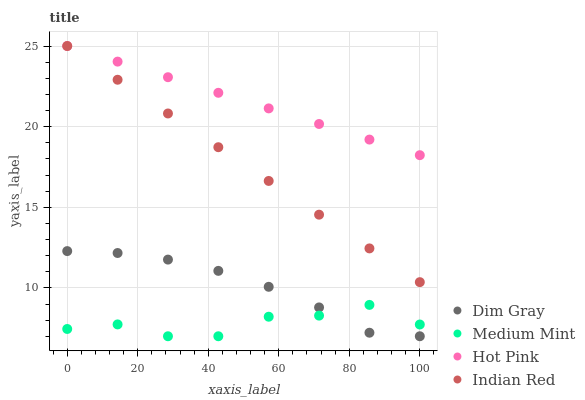Does Medium Mint have the minimum area under the curve?
Answer yes or no. Yes. Does Hot Pink have the maximum area under the curve?
Answer yes or no. Yes. Does Dim Gray have the minimum area under the curve?
Answer yes or no. No. Does Dim Gray have the maximum area under the curve?
Answer yes or no. No. Is Indian Red the smoothest?
Answer yes or no. Yes. Is Medium Mint the roughest?
Answer yes or no. Yes. Is Dim Gray the smoothest?
Answer yes or no. No. Is Dim Gray the roughest?
Answer yes or no. No. Does Medium Mint have the lowest value?
Answer yes or no. Yes. Does Indian Red have the lowest value?
Answer yes or no. No. Does Hot Pink have the highest value?
Answer yes or no. Yes. Does Dim Gray have the highest value?
Answer yes or no. No. Is Medium Mint less than Indian Red?
Answer yes or no. Yes. Is Indian Red greater than Medium Mint?
Answer yes or no. Yes. Does Dim Gray intersect Medium Mint?
Answer yes or no. Yes. Is Dim Gray less than Medium Mint?
Answer yes or no. No. Is Dim Gray greater than Medium Mint?
Answer yes or no. No. Does Medium Mint intersect Indian Red?
Answer yes or no. No. 